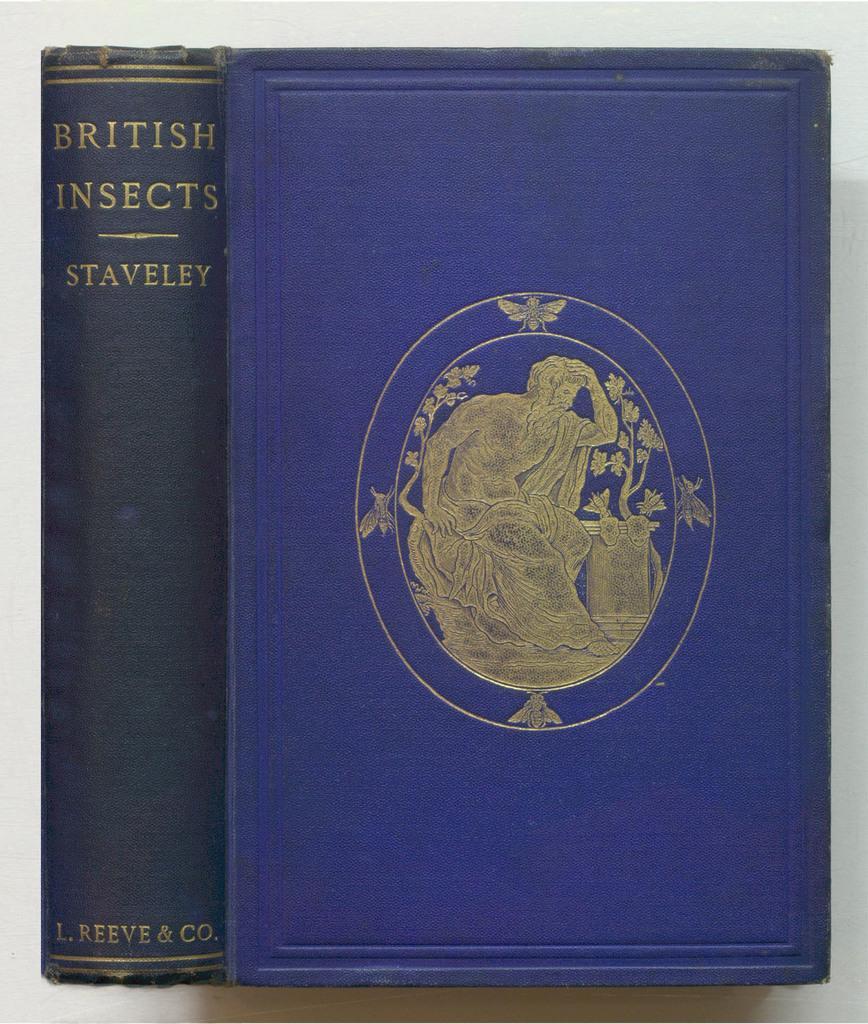How would you summarize this image in a sentence or two? In this image we can see, this look like a book and it is of blue color. 